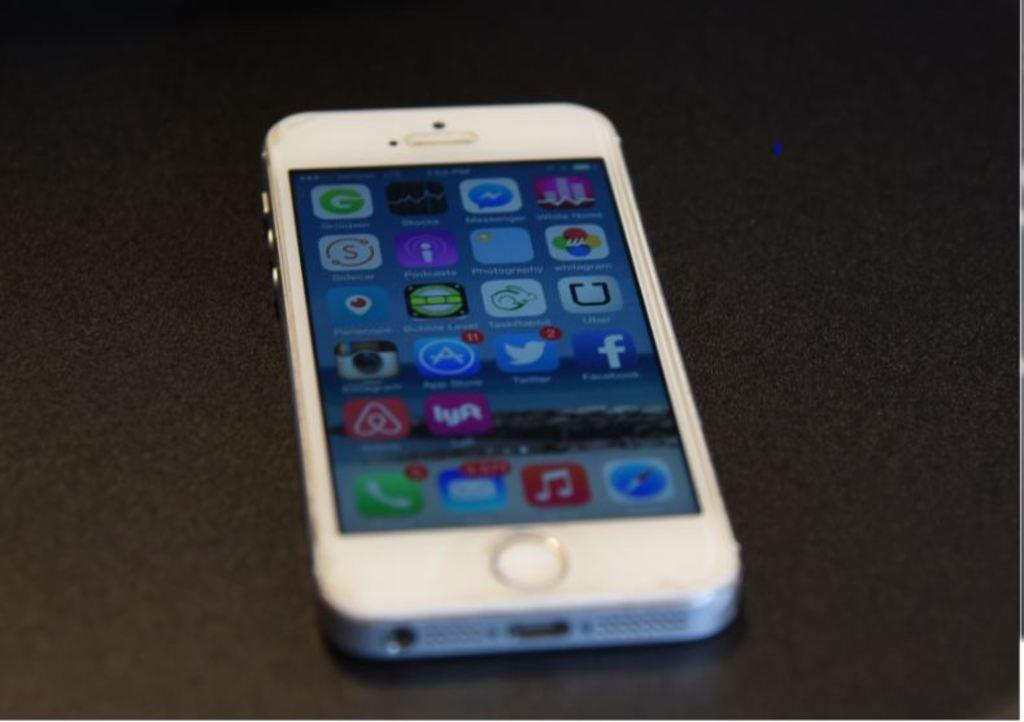<image>
Create a compact narrative representing the image presented. Apps such as Facbook are displayed on the cell phone screen. 